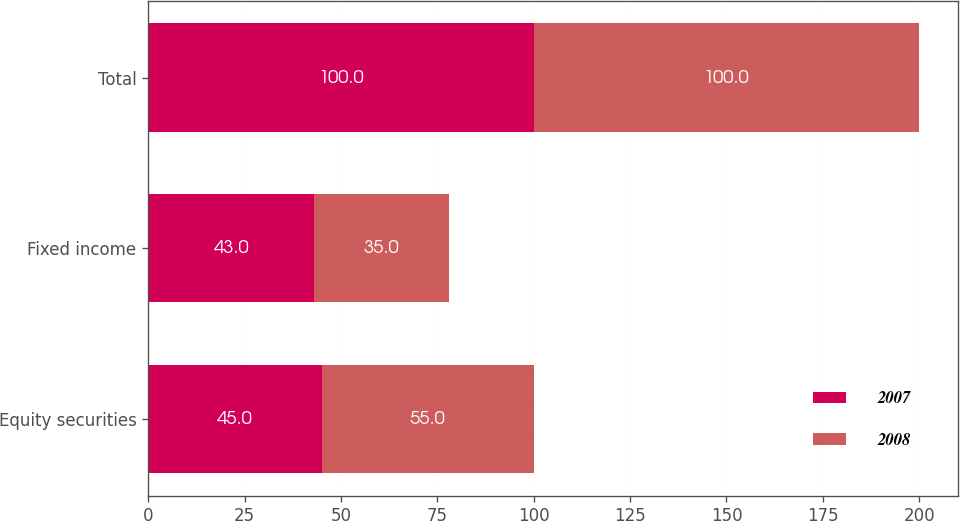<chart> <loc_0><loc_0><loc_500><loc_500><stacked_bar_chart><ecel><fcel>Equity securities<fcel>Fixed income<fcel>Total<nl><fcel>2007<fcel>45<fcel>43<fcel>100<nl><fcel>2008<fcel>55<fcel>35<fcel>100<nl></chart> 